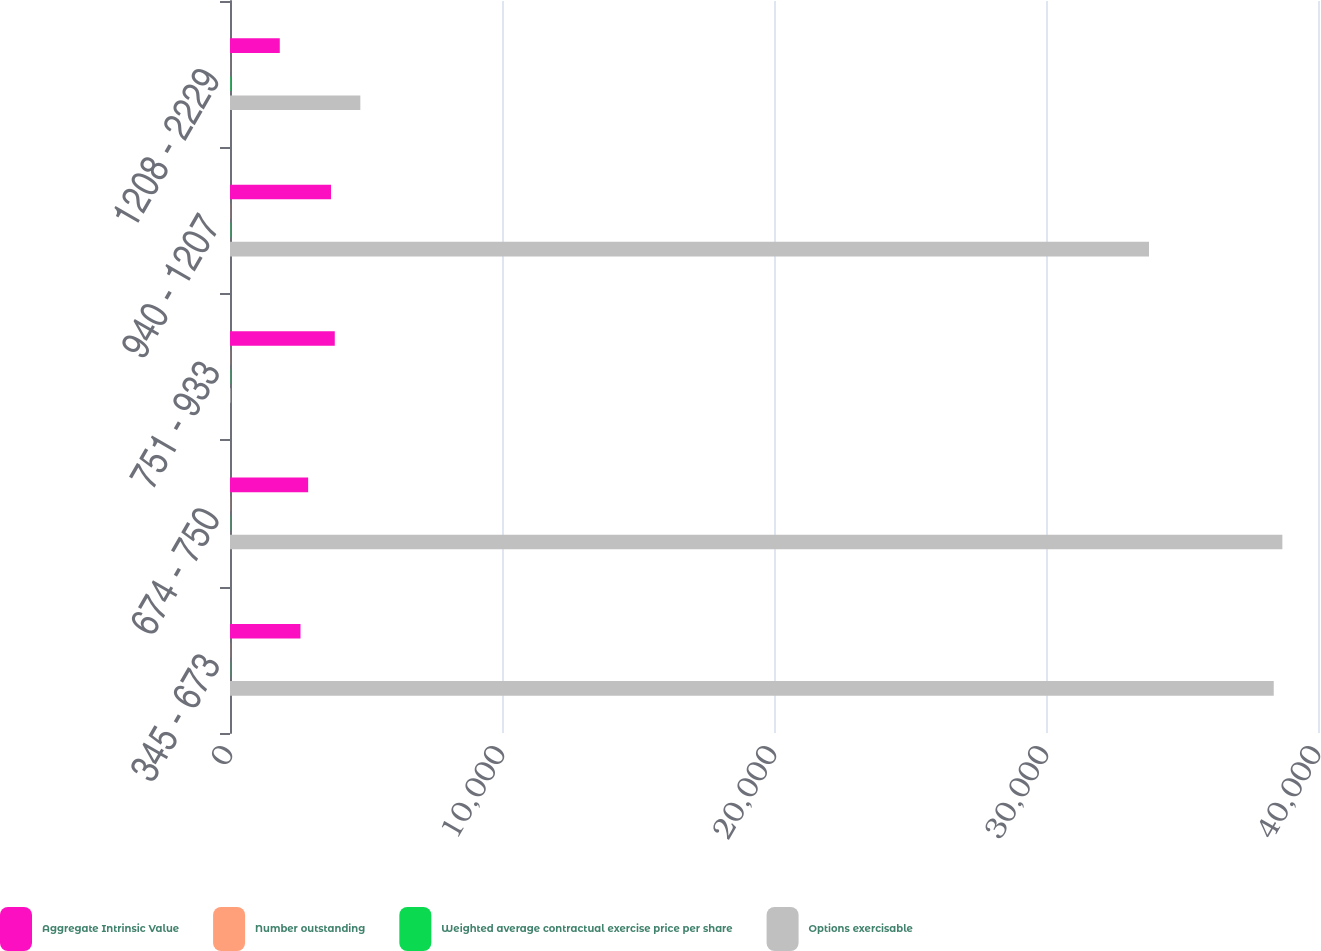Convert chart to OTSL. <chart><loc_0><loc_0><loc_500><loc_500><stacked_bar_chart><ecel><fcel>345 - 673<fcel>674 - 750<fcel>751 - 933<fcel>940 - 1207<fcel>1208 - 2229<nl><fcel>Aggregate Intrinsic Value<fcel>2591<fcel>2873<fcel>3852<fcel>3714<fcel>1830<nl><fcel>Number outstanding<fcel>4.6<fcel>6.2<fcel>5<fcel>5.4<fcel>2.6<nl><fcel>Weighted average contractual exercise price per share<fcel>5.84<fcel>7.19<fcel>9.14<fcel>11.55<fcel>18.41<nl><fcel>Options exercisable<fcel>38373<fcel>38690<fcel>18.41<fcel>33787<fcel>4792<nl></chart> 